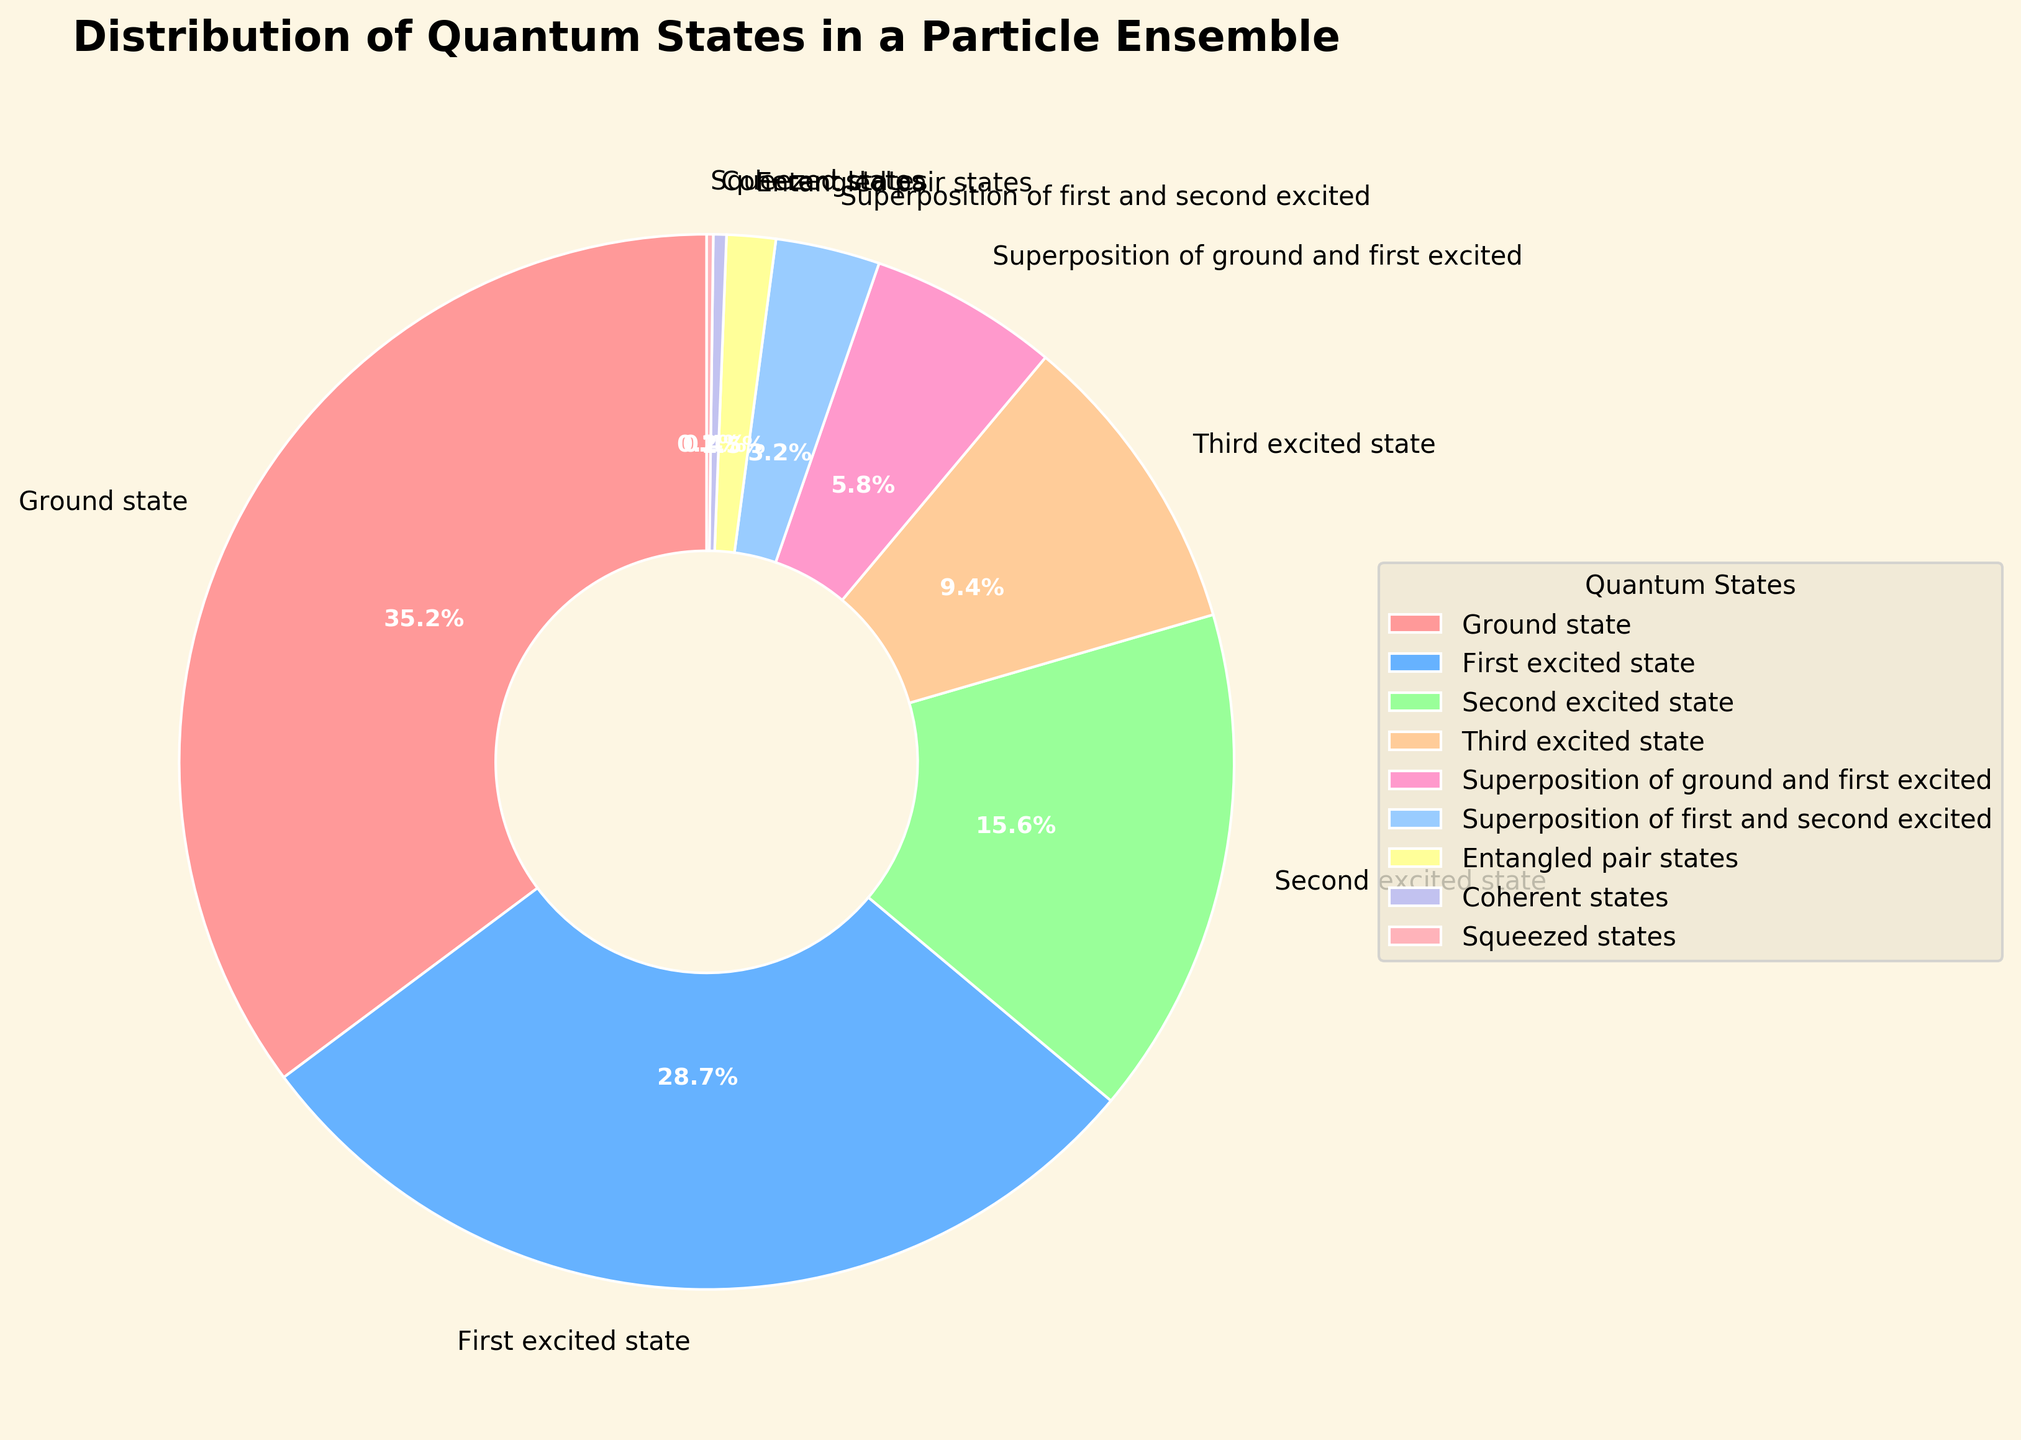What percentage of the particle ensemble is in either the ground state or the first excited state? Sum the percentages of the ground state (35.2%) and the first excited state (28.7%). The total is 35.2% + 28.7% = 63.9%.
Answer: 63.9% Which quantum state has the smallest representation in the particle ensemble? Identify the state with the smallest percentage. The squeezed states have the smallest representation at 0.2%.
Answer: Squeezed states What is the difference in percentage between the ground state and the second excited state? Subtract the percentage of the second excited state (15.6%) from the ground state (35.2%). The difference is 35.2% - 15.6% = 19.6%.
Answer: 19.6% Which quantum states have a higher percentage than the third excited state? Compare the percentages of all states with the third excited state (9.4%). The ground state (35.2%), first excited state (28.7%), and second excited state (15.6%) have higher percentages.
Answer: Ground state, First excited state, Second excited state What is the combined percentage of all superposition and entangled pair states? Add the percentages of the superposition of ground and first excited (5.8%), superposition of first and second excited (3.2%), and entangled pair states (1.5%). The total is 5.8% + 3.2% + 1.5% = 10.5%.
Answer: 10.5% Which two quantum states have the closest percentages, and what is the difference? Compare all percentage differences: First excited state and second excited state have the closest percentages with a difference of 28.7% - 15.6% = 13.1%.
Answer: First excited state and Second excited state, 13.1% Which state appears as the third largest portion in the pie chart? Rank the states by percentage to find the third largest. The ground state is first (35.2%), the first excited state is second (28.7%), and the second excited state is third (15.6%).
Answer: Second excited state What is the percentage contribution of coherent states and squeezed states together? Add the percentages of coherent states (0.4%) and squeezed states (0.2%). The total is 0.4% + 0.2% = 0.6%.
Answer: 0.6% 